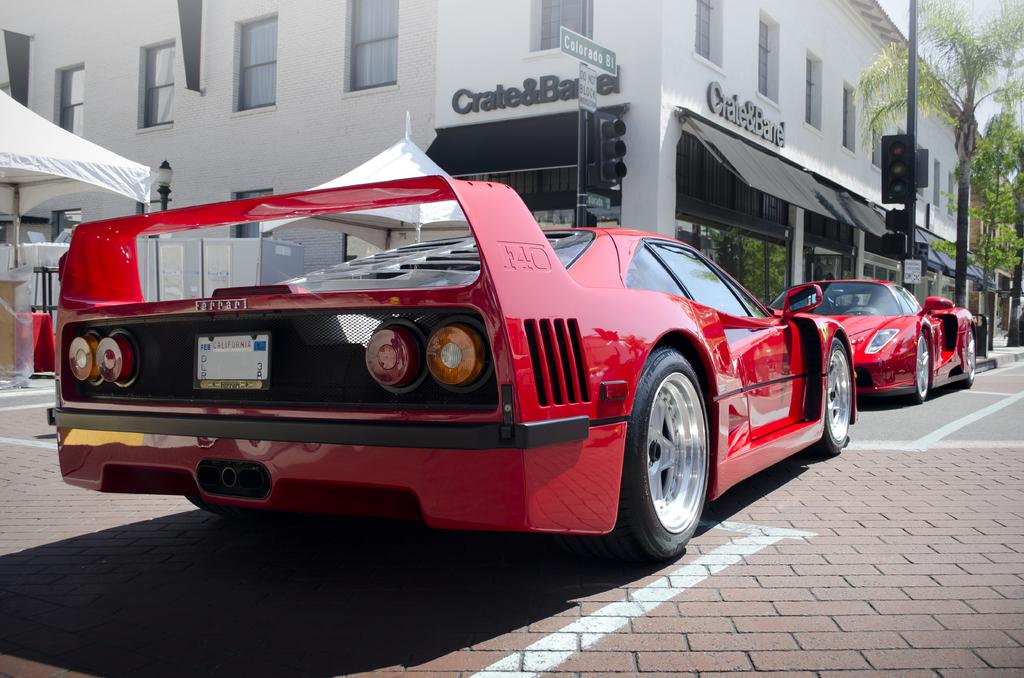What color are the cars in the image? The cars in the image are red. What type of structures can be seen in the image? There are buildings in the image. What architectural feature is present in the buildings? There are windows in the image. What type of temporary shelter is present in the image? There is a tent in the image. What type of vegetation is present in the image? There are trees in the image. What part of the natural environment is visible in the image? The sky is visible in the image. How many dogs are playing volleyball in the image? There are no dogs or volleyballs present in the image. 